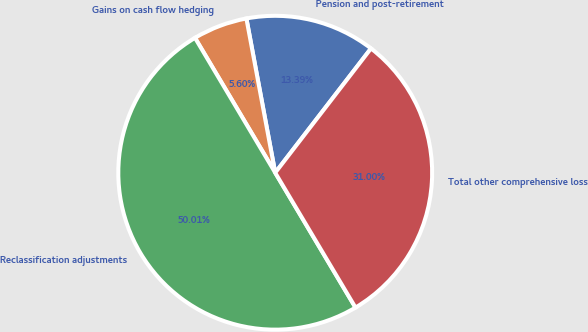Convert chart to OTSL. <chart><loc_0><loc_0><loc_500><loc_500><pie_chart><fcel>Pension and post-retirement<fcel>Gains on cash flow hedging<fcel>Reclassification adjustments<fcel>Total other comprehensive loss<nl><fcel>13.39%<fcel>5.6%<fcel>50.0%<fcel>31.0%<nl></chart> 